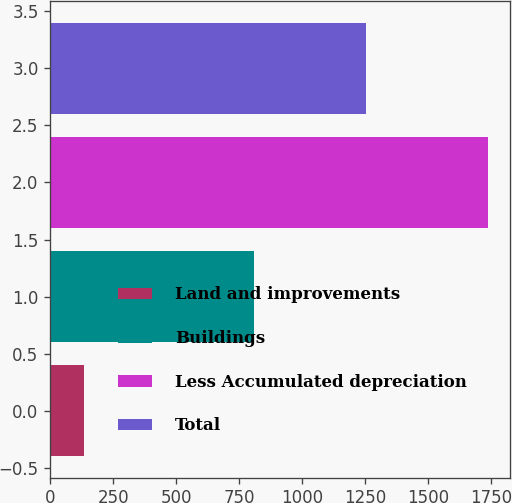Convert chart to OTSL. <chart><loc_0><loc_0><loc_500><loc_500><bar_chart><fcel>Land and improvements<fcel>Buildings<fcel>Less Accumulated depreciation<fcel>Total<nl><fcel>135<fcel>809<fcel>1738<fcel>1252<nl></chart> 